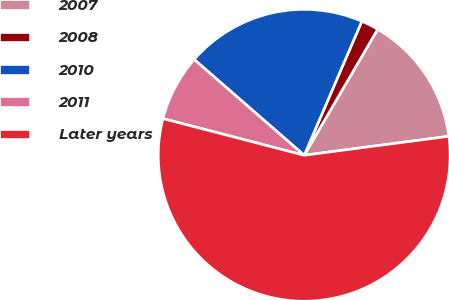<chart> <loc_0><loc_0><loc_500><loc_500><pie_chart><fcel>2007<fcel>2008<fcel>2010<fcel>2011<fcel>Later years<nl><fcel>14.52%<fcel>1.94%<fcel>20.06%<fcel>7.36%<fcel>56.13%<nl></chart> 